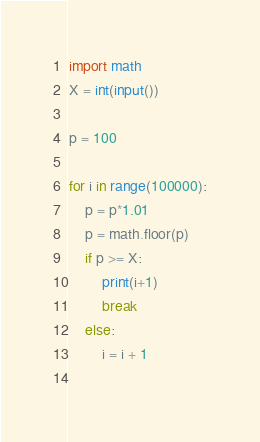Convert code to text. <code><loc_0><loc_0><loc_500><loc_500><_Python_>import math
X = int(input())

p = 100

for i in range(100000):
    p = p*1.01
    p = math.floor(p)
    if p >= X:
        print(i+1)
        break
    else:
        i = i + 1
    </code> 